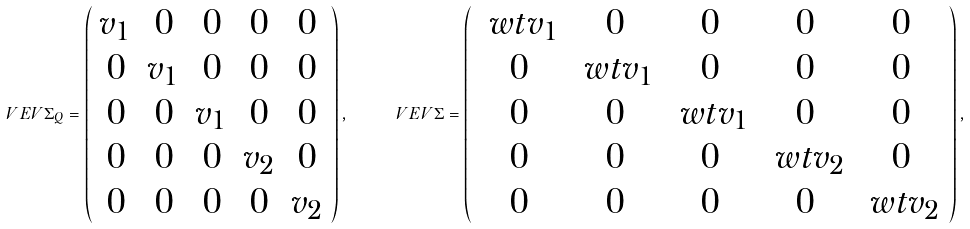<formula> <loc_0><loc_0><loc_500><loc_500>\ V E V { \Sigma _ { Q } } = \left ( \begin{array} { c c c c c } v _ { 1 } & 0 & 0 & 0 & 0 \\ 0 & v _ { 1 } & 0 & 0 & 0 \\ 0 & 0 & v _ { 1 } & 0 & 0 \\ 0 & 0 & 0 & v _ { 2 } & 0 \\ 0 & 0 & 0 & 0 & v _ { 2 } \\ \end{array} \right ) , \quad \ V E V { \Sigma } = \left ( \begin{array} { c c c c c } \ w t v _ { 1 } & 0 & 0 & 0 & 0 \\ 0 & \ w t v _ { 1 } & 0 & 0 & 0 \\ 0 & 0 & \ w t v _ { 1 } & 0 & 0 \\ 0 & 0 & 0 & \ w t v _ { 2 } & 0 \\ 0 & 0 & 0 & 0 & \ w t v _ { 2 } \\ \end{array} \right ) ,</formula> 